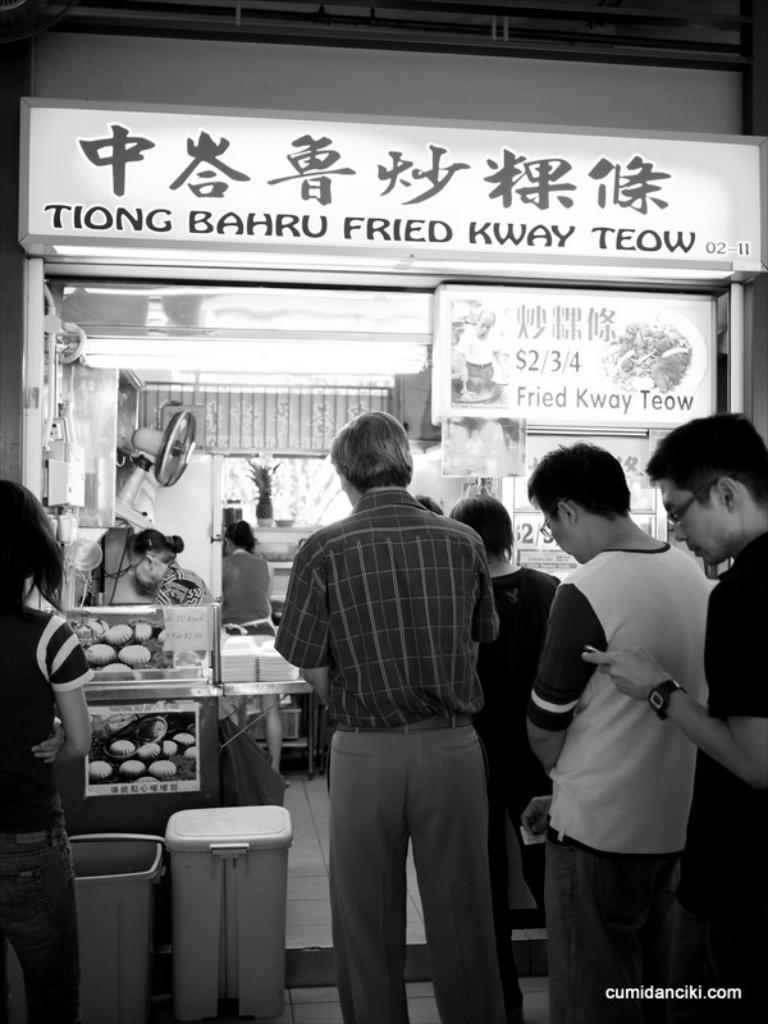<image>
Create a compact narrative representing the image presented. Tiong Bahru Fried Kway Teow has a line of people waiting for food. 